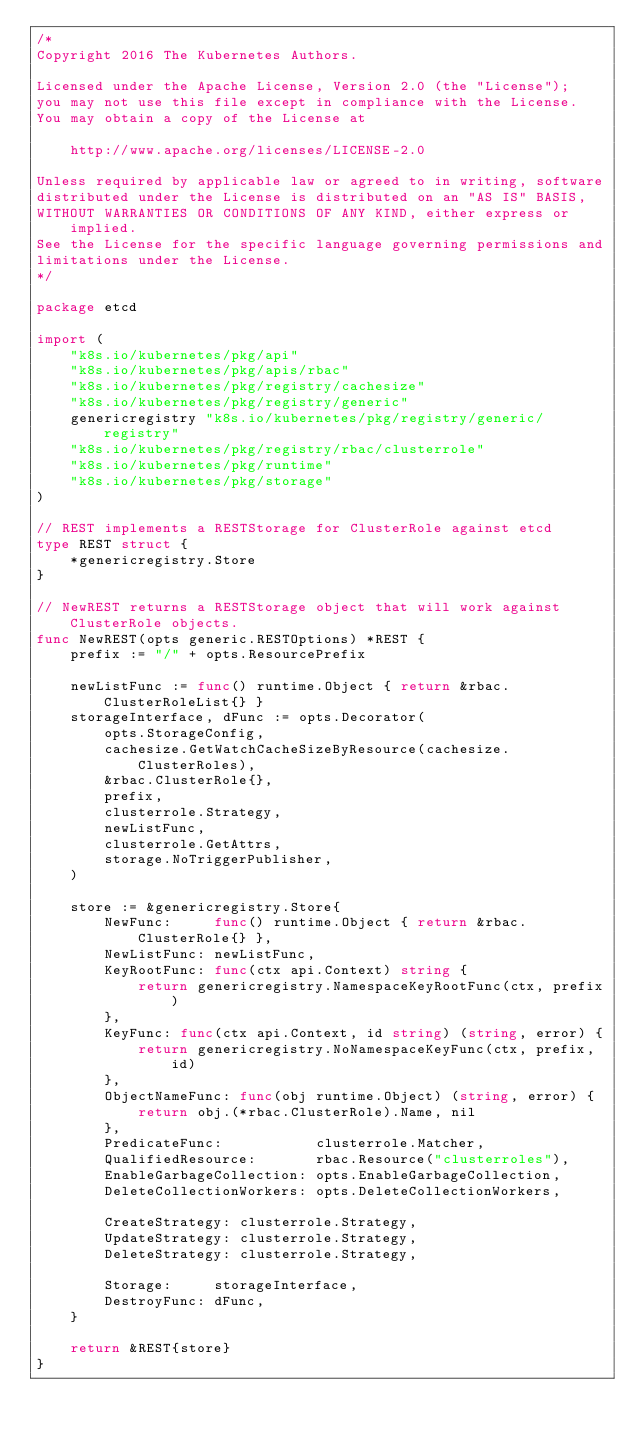<code> <loc_0><loc_0><loc_500><loc_500><_Go_>/*
Copyright 2016 The Kubernetes Authors.

Licensed under the Apache License, Version 2.0 (the "License");
you may not use this file except in compliance with the License.
You may obtain a copy of the License at

    http://www.apache.org/licenses/LICENSE-2.0

Unless required by applicable law or agreed to in writing, software
distributed under the License is distributed on an "AS IS" BASIS,
WITHOUT WARRANTIES OR CONDITIONS OF ANY KIND, either express or implied.
See the License for the specific language governing permissions and
limitations under the License.
*/

package etcd

import (
	"k8s.io/kubernetes/pkg/api"
	"k8s.io/kubernetes/pkg/apis/rbac"
	"k8s.io/kubernetes/pkg/registry/cachesize"
	"k8s.io/kubernetes/pkg/registry/generic"
	genericregistry "k8s.io/kubernetes/pkg/registry/generic/registry"
	"k8s.io/kubernetes/pkg/registry/rbac/clusterrole"
	"k8s.io/kubernetes/pkg/runtime"
	"k8s.io/kubernetes/pkg/storage"
)

// REST implements a RESTStorage for ClusterRole against etcd
type REST struct {
	*genericregistry.Store
}

// NewREST returns a RESTStorage object that will work against ClusterRole objects.
func NewREST(opts generic.RESTOptions) *REST {
	prefix := "/" + opts.ResourcePrefix

	newListFunc := func() runtime.Object { return &rbac.ClusterRoleList{} }
	storageInterface, dFunc := opts.Decorator(
		opts.StorageConfig,
		cachesize.GetWatchCacheSizeByResource(cachesize.ClusterRoles),
		&rbac.ClusterRole{},
		prefix,
		clusterrole.Strategy,
		newListFunc,
		clusterrole.GetAttrs,
		storage.NoTriggerPublisher,
	)

	store := &genericregistry.Store{
		NewFunc:     func() runtime.Object { return &rbac.ClusterRole{} },
		NewListFunc: newListFunc,
		KeyRootFunc: func(ctx api.Context) string {
			return genericregistry.NamespaceKeyRootFunc(ctx, prefix)
		},
		KeyFunc: func(ctx api.Context, id string) (string, error) {
			return genericregistry.NoNamespaceKeyFunc(ctx, prefix, id)
		},
		ObjectNameFunc: func(obj runtime.Object) (string, error) {
			return obj.(*rbac.ClusterRole).Name, nil
		},
		PredicateFunc:           clusterrole.Matcher,
		QualifiedResource:       rbac.Resource("clusterroles"),
		EnableGarbageCollection: opts.EnableGarbageCollection,
		DeleteCollectionWorkers: opts.DeleteCollectionWorkers,

		CreateStrategy: clusterrole.Strategy,
		UpdateStrategy: clusterrole.Strategy,
		DeleteStrategy: clusterrole.Strategy,

		Storage:     storageInterface,
		DestroyFunc: dFunc,
	}

	return &REST{store}
}
</code> 